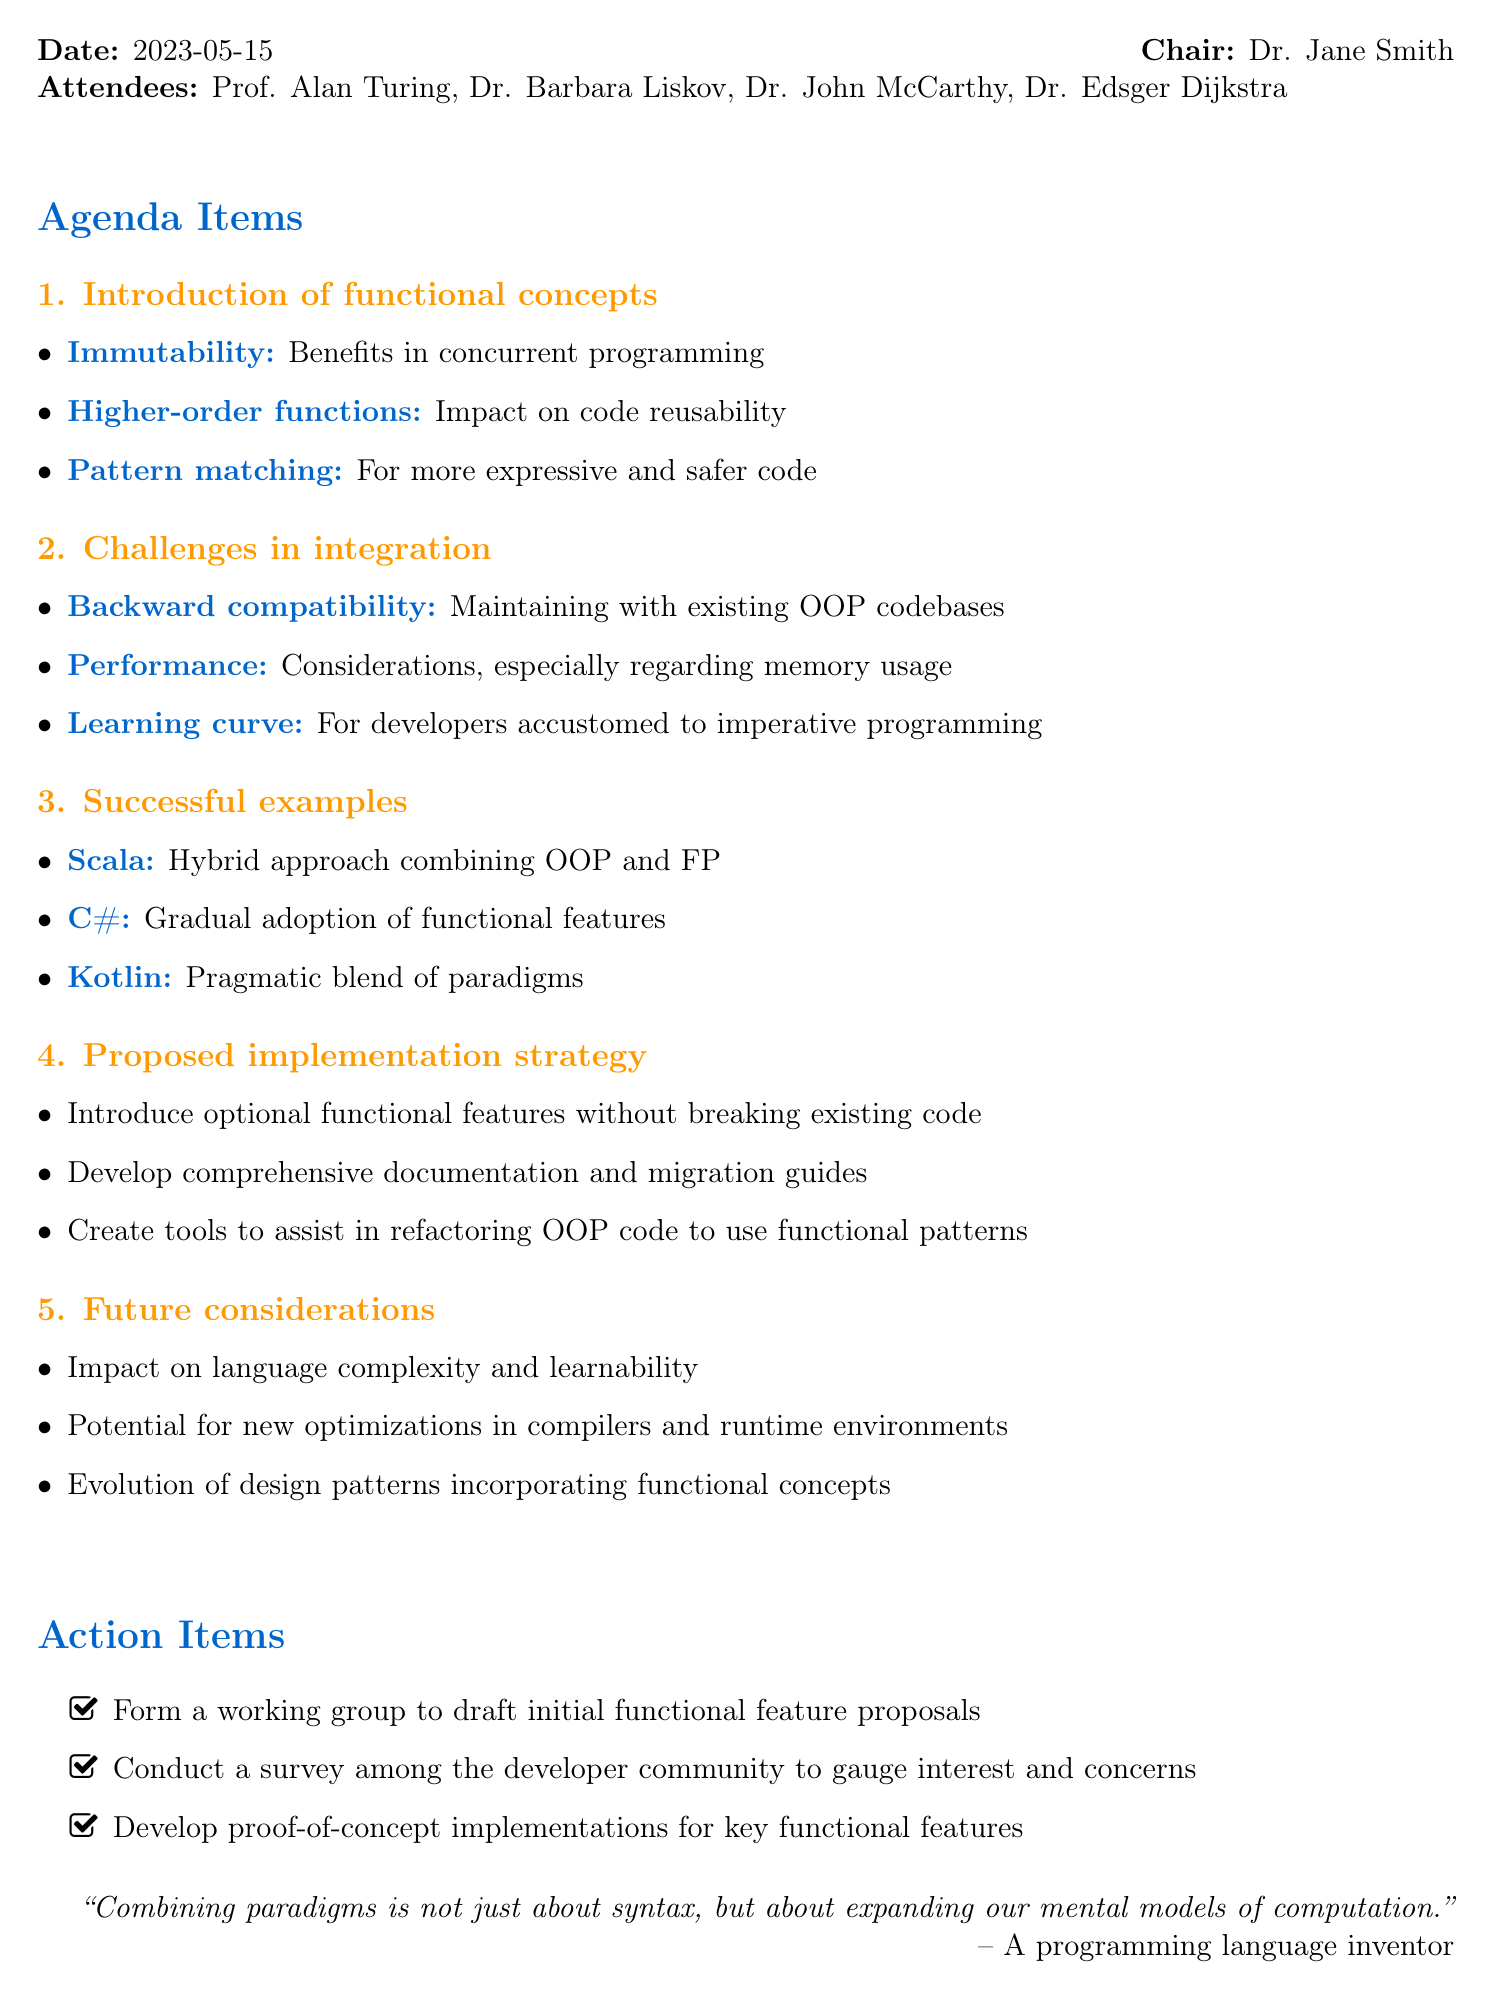What was the date of the meeting? The date of the meeting is mentioned at the beginning of the document.
Answer: 2023-05-15 Who chaired the meeting? The document specifies who led the meeting in the introductory section.
Answer: Dr. Jane Smith What is one of the challenges in integration? The challenges are listed under a specific agenda item in the document.
Answer: Backward compatibility Name one successful example of FP integration mentioned. The document provides specific examples of languages that have successfully integrated FP.
Answer: Scala What is one proposed action item from the meeting? The action items are clearly stated at the end of the document.
Answer: Form a working group What are the proposed implementation strategies? Strategies for implementing functional features are outlined in a specific agenda section.
Answer: Introduce optional functional features without breaking existing code What is one future consideration about introducing functional programming? Future considerations are listed towards the end of the document, focusing on various implications.
Answer: Impact on language complexity and learnability How many attendees were present at the meeting? The number of attendees can be counted from the attendees list in the document.
Answer: Five 